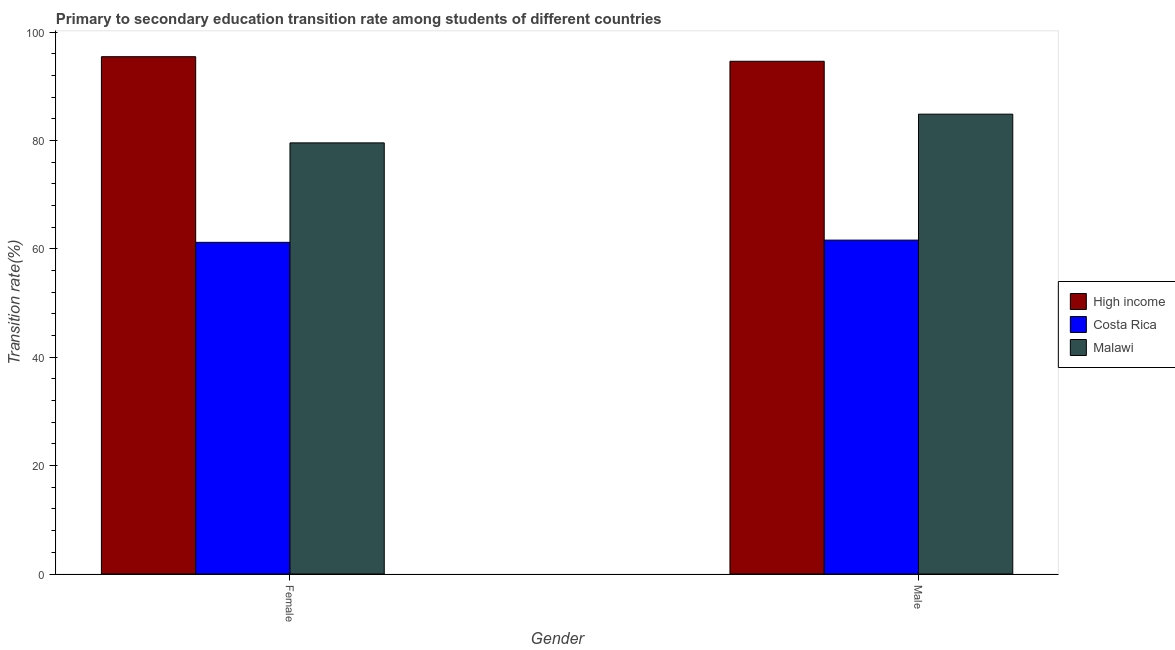How many different coloured bars are there?
Offer a very short reply. 3. Are the number of bars on each tick of the X-axis equal?
Give a very brief answer. Yes. How many bars are there on the 1st tick from the left?
Your answer should be compact. 3. How many bars are there on the 2nd tick from the right?
Offer a terse response. 3. What is the label of the 2nd group of bars from the left?
Your answer should be very brief. Male. What is the transition rate among female students in Malawi?
Provide a short and direct response. 79.58. Across all countries, what is the maximum transition rate among female students?
Ensure brevity in your answer.  95.49. Across all countries, what is the minimum transition rate among female students?
Provide a short and direct response. 61.22. In which country was the transition rate among female students maximum?
Provide a succinct answer. High income. What is the total transition rate among male students in the graph?
Keep it short and to the point. 241.15. What is the difference between the transition rate among female students in Costa Rica and that in Malawi?
Keep it short and to the point. -18.36. What is the difference between the transition rate among male students in Costa Rica and the transition rate among female students in Malawi?
Offer a terse response. -17.95. What is the average transition rate among male students per country?
Provide a short and direct response. 80.38. What is the difference between the transition rate among female students and transition rate among male students in High income?
Keep it short and to the point. 0.85. What is the ratio of the transition rate among female students in High income to that in Malawi?
Offer a very short reply. 1.2. Is the transition rate among male students in Malawi less than that in High income?
Provide a short and direct response. Yes. In how many countries, is the transition rate among male students greater than the average transition rate among male students taken over all countries?
Provide a short and direct response. 2. What does the 2nd bar from the left in Male represents?
Offer a terse response. Costa Rica. How many bars are there?
Keep it short and to the point. 6. What is the difference between two consecutive major ticks on the Y-axis?
Provide a succinct answer. 20. Are the values on the major ticks of Y-axis written in scientific E-notation?
Your response must be concise. No. Does the graph contain grids?
Your response must be concise. No. Where does the legend appear in the graph?
Ensure brevity in your answer.  Center right. What is the title of the graph?
Your answer should be very brief. Primary to secondary education transition rate among students of different countries. What is the label or title of the X-axis?
Your response must be concise. Gender. What is the label or title of the Y-axis?
Give a very brief answer. Transition rate(%). What is the Transition rate(%) of High income in Female?
Offer a terse response. 95.49. What is the Transition rate(%) in Costa Rica in Female?
Keep it short and to the point. 61.22. What is the Transition rate(%) of Malawi in Female?
Make the answer very short. 79.58. What is the Transition rate(%) of High income in Male?
Offer a terse response. 94.64. What is the Transition rate(%) in Costa Rica in Male?
Ensure brevity in your answer.  61.63. What is the Transition rate(%) of Malawi in Male?
Offer a very short reply. 84.88. Across all Gender, what is the maximum Transition rate(%) of High income?
Your answer should be very brief. 95.49. Across all Gender, what is the maximum Transition rate(%) of Costa Rica?
Provide a succinct answer. 61.63. Across all Gender, what is the maximum Transition rate(%) in Malawi?
Provide a succinct answer. 84.88. Across all Gender, what is the minimum Transition rate(%) in High income?
Provide a succinct answer. 94.64. Across all Gender, what is the minimum Transition rate(%) of Costa Rica?
Offer a terse response. 61.22. Across all Gender, what is the minimum Transition rate(%) in Malawi?
Offer a terse response. 79.58. What is the total Transition rate(%) of High income in the graph?
Your answer should be compact. 190.13. What is the total Transition rate(%) in Costa Rica in the graph?
Keep it short and to the point. 122.85. What is the total Transition rate(%) in Malawi in the graph?
Provide a short and direct response. 164.45. What is the difference between the Transition rate(%) in High income in Female and that in Male?
Keep it short and to the point. 0.85. What is the difference between the Transition rate(%) in Costa Rica in Female and that in Male?
Your answer should be compact. -0.41. What is the difference between the Transition rate(%) of Malawi in Female and that in Male?
Make the answer very short. -5.3. What is the difference between the Transition rate(%) of High income in Female and the Transition rate(%) of Costa Rica in Male?
Make the answer very short. 33.86. What is the difference between the Transition rate(%) in High income in Female and the Transition rate(%) in Malawi in Male?
Ensure brevity in your answer.  10.61. What is the difference between the Transition rate(%) of Costa Rica in Female and the Transition rate(%) of Malawi in Male?
Give a very brief answer. -23.66. What is the average Transition rate(%) in High income per Gender?
Keep it short and to the point. 95.06. What is the average Transition rate(%) of Costa Rica per Gender?
Make the answer very short. 61.42. What is the average Transition rate(%) in Malawi per Gender?
Your answer should be very brief. 82.23. What is the difference between the Transition rate(%) in High income and Transition rate(%) in Costa Rica in Female?
Make the answer very short. 34.27. What is the difference between the Transition rate(%) of High income and Transition rate(%) of Malawi in Female?
Provide a succinct answer. 15.91. What is the difference between the Transition rate(%) in Costa Rica and Transition rate(%) in Malawi in Female?
Ensure brevity in your answer.  -18.36. What is the difference between the Transition rate(%) in High income and Transition rate(%) in Costa Rica in Male?
Your answer should be compact. 33.01. What is the difference between the Transition rate(%) of High income and Transition rate(%) of Malawi in Male?
Make the answer very short. 9.76. What is the difference between the Transition rate(%) of Costa Rica and Transition rate(%) of Malawi in Male?
Keep it short and to the point. -23.25. What is the ratio of the Transition rate(%) in High income in Female to that in Male?
Offer a terse response. 1.01. What is the ratio of the Transition rate(%) in Malawi in Female to that in Male?
Offer a terse response. 0.94. What is the difference between the highest and the second highest Transition rate(%) in High income?
Keep it short and to the point. 0.85. What is the difference between the highest and the second highest Transition rate(%) of Costa Rica?
Your answer should be very brief. 0.41. What is the difference between the highest and the second highest Transition rate(%) of Malawi?
Keep it short and to the point. 5.3. What is the difference between the highest and the lowest Transition rate(%) in High income?
Your answer should be compact. 0.85. What is the difference between the highest and the lowest Transition rate(%) of Costa Rica?
Your answer should be compact. 0.41. What is the difference between the highest and the lowest Transition rate(%) of Malawi?
Keep it short and to the point. 5.3. 